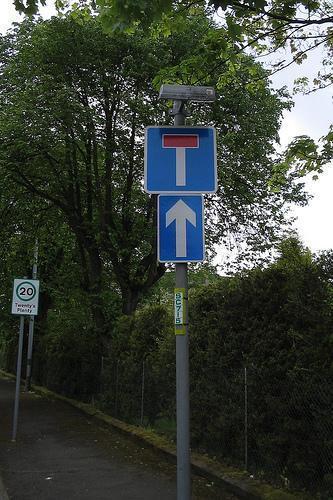How many arrows are there?
Give a very brief answer. 1. 